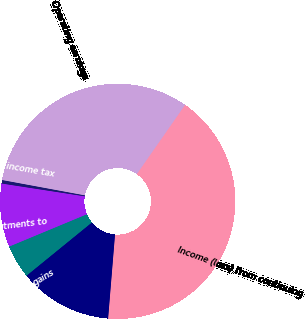Convert chart to OTSL. <chart><loc_0><loc_0><loc_500><loc_500><pie_chart><fcel>Income (loss) from continuing<fcel>Less Net investment gains<fcel>Less Net derivative gains<fcel>Less Other adjustments to<fcel>Less Provision for income tax<fcel>Operating earnings<nl><fcel>41.61%<fcel>12.82%<fcel>4.6%<fcel>8.71%<fcel>0.48%<fcel>31.78%<nl></chart> 